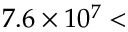<formula> <loc_0><loc_0><loc_500><loc_500>7 . 6 \times 1 0 ^ { 7 } <</formula> 